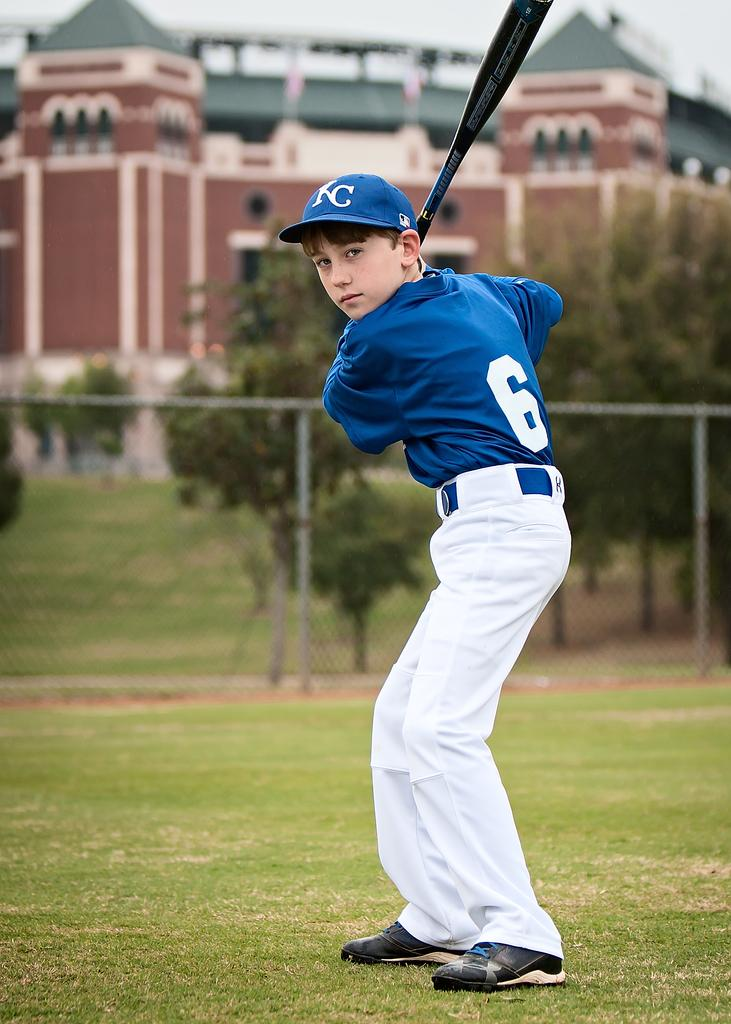Provide a one-sentence caption for the provided image. A young baseball player wearing a blue shirt with the number 6 on it is up to bat. 